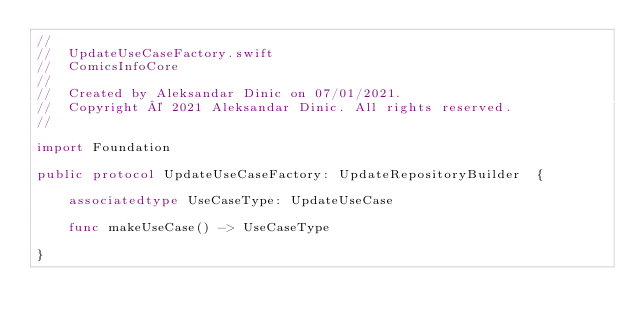<code> <loc_0><loc_0><loc_500><loc_500><_Swift_>//
//  UpdateUseCaseFactory.swift
//  ComicsInfoCore
//
//  Created by Aleksandar Dinic on 07/01/2021.
//  Copyright © 2021 Aleksandar Dinic. All rights reserved.
//

import Foundation

public protocol UpdateUseCaseFactory: UpdateRepositoryBuilder  {

    associatedtype UseCaseType: UpdateUseCase

    func makeUseCase() -> UseCaseType

}
</code> 